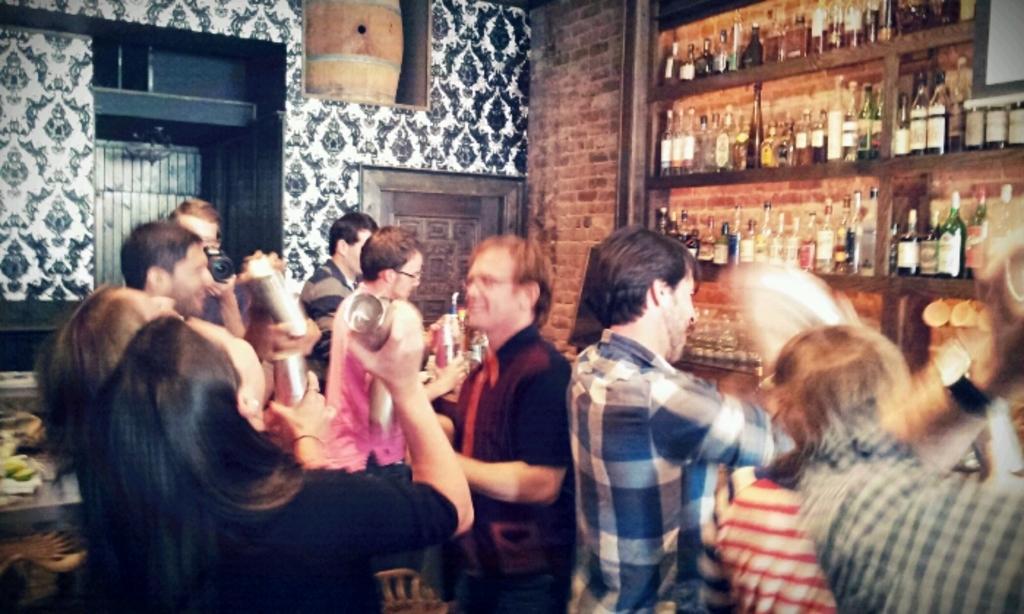Please provide a concise description of this image. In this image on the ground there are many people. On the shelf there are many liquor bottles. On the table there are bottles. A person is clicking pictures. People are holding something. In the background there is barrel, wall, window, and few other things are there. 